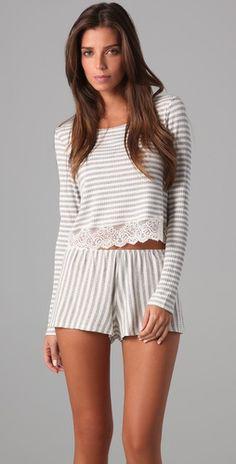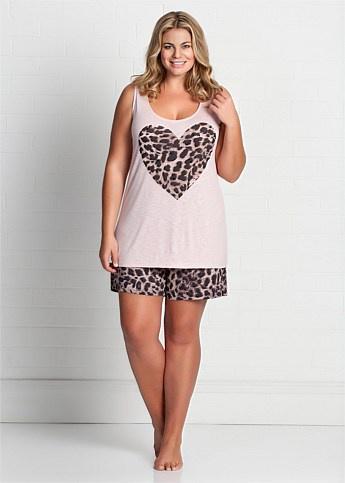The first image is the image on the left, the second image is the image on the right. For the images displayed, is the sentence "One woman wears shorts while the other wears pants." factually correct? Answer yes or no. No. The first image is the image on the left, the second image is the image on the right. Evaluate the accuracy of this statement regarding the images: "Of two pajama sets, one is pink with long sleeves and pants, while the other is a matching set of top with short pants.". Is it true? Answer yes or no. No. 